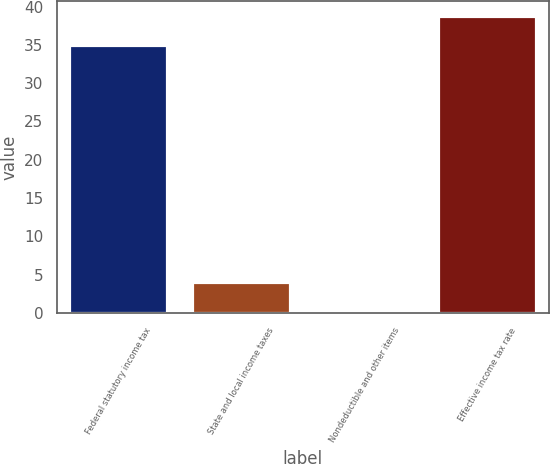Convert chart. <chart><loc_0><loc_0><loc_500><loc_500><bar_chart><fcel>Federal statutory income tax<fcel>State and local income taxes<fcel>Nondeductible and other items<fcel>Effective income tax rate<nl><fcel>35<fcel>3.98<fcel>0.2<fcel>38.78<nl></chart> 